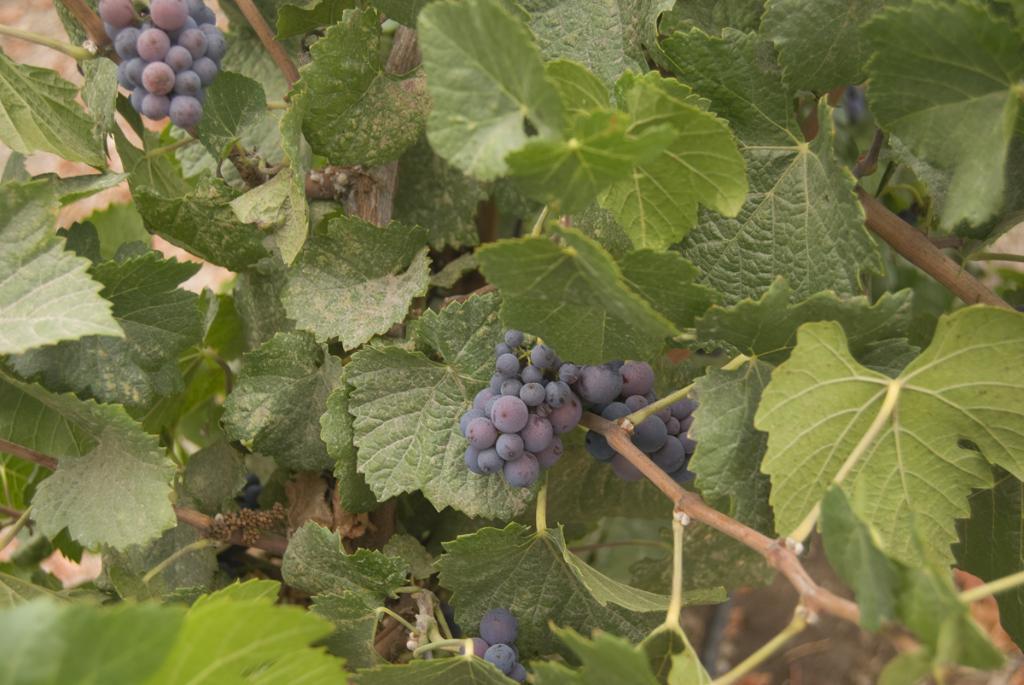Can you describe this image briefly? In this image we can see bunch of fruits looks like grapes to the tree. 